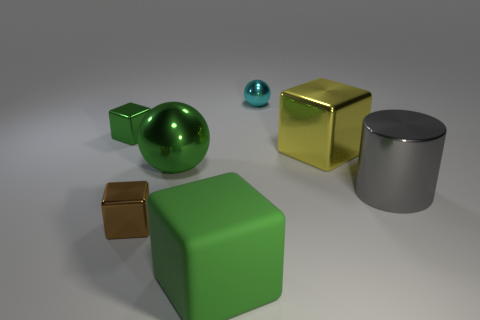Subtract all small green blocks. How many blocks are left? 3 Subtract all purple cylinders. How many green blocks are left? 2 Subtract all brown blocks. How many blocks are left? 3 Subtract 1 cubes. How many cubes are left? 3 Add 3 large rubber blocks. How many objects exist? 10 Subtract all brown cubes. Subtract all blue spheres. How many cubes are left? 3 Subtract all cylinders. How many objects are left? 6 Add 3 large red shiny things. How many large red shiny things exist? 3 Subtract 0 gray balls. How many objects are left? 7 Subtract all cylinders. Subtract all metallic balls. How many objects are left? 4 